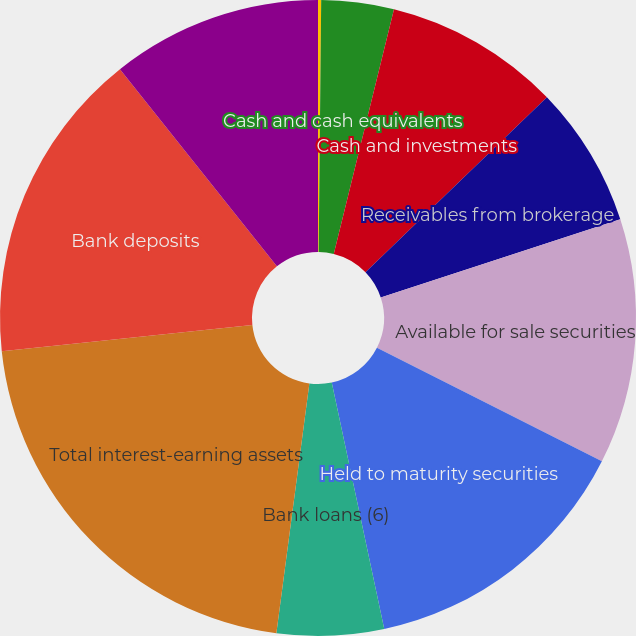<chart> <loc_0><loc_0><loc_500><loc_500><pie_chart><fcel>For the Year Ended December 31<fcel>Cash and cash equivalents<fcel>Cash and investments<fcel>Receivables from brokerage<fcel>Available for sale securities<fcel>Held to maturity securities<fcel>Bank loans (6)<fcel>Total interest-earning assets<fcel>Bank deposits<fcel>Payables to brokerage clients<nl><fcel>0.16%<fcel>3.68%<fcel>8.95%<fcel>7.19%<fcel>12.46%<fcel>14.22%<fcel>5.43%<fcel>21.24%<fcel>15.97%<fcel>10.7%<nl></chart> 